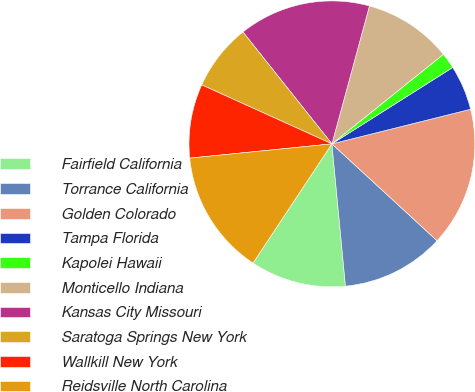Convert chart to OTSL. <chart><loc_0><loc_0><loc_500><loc_500><pie_chart><fcel>Fairfield California<fcel>Torrance California<fcel>Golden Colorado<fcel>Tampa Florida<fcel>Kapolei Hawaii<fcel>Monticello Indiana<fcel>Kansas City Missouri<fcel>Saratoga Springs New York<fcel>Wallkill New York<fcel>Reidsville North Carolina<nl><fcel>10.82%<fcel>11.64%<fcel>15.74%<fcel>5.08%<fcel>1.8%<fcel>10.0%<fcel>14.92%<fcel>7.54%<fcel>8.36%<fcel>14.1%<nl></chart> 